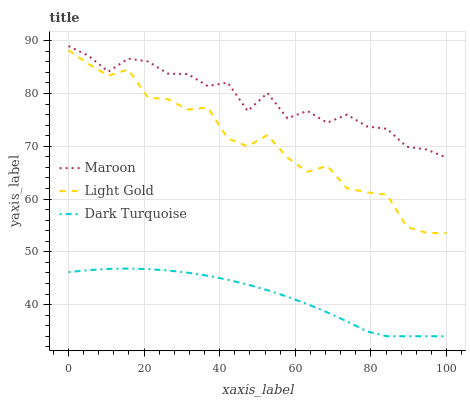Does Dark Turquoise have the minimum area under the curve?
Answer yes or no. Yes. Does Maroon have the maximum area under the curve?
Answer yes or no. Yes. Does Light Gold have the minimum area under the curve?
Answer yes or no. No. Does Light Gold have the maximum area under the curve?
Answer yes or no. No. Is Dark Turquoise the smoothest?
Answer yes or no. Yes. Is Maroon the roughest?
Answer yes or no. Yes. Is Light Gold the smoothest?
Answer yes or no. No. Is Light Gold the roughest?
Answer yes or no. No. Does Dark Turquoise have the lowest value?
Answer yes or no. Yes. Does Light Gold have the lowest value?
Answer yes or no. No. Does Maroon have the highest value?
Answer yes or no. Yes. Does Light Gold have the highest value?
Answer yes or no. No. Is Dark Turquoise less than Light Gold?
Answer yes or no. Yes. Is Light Gold greater than Dark Turquoise?
Answer yes or no. Yes. Does Dark Turquoise intersect Light Gold?
Answer yes or no. No. 